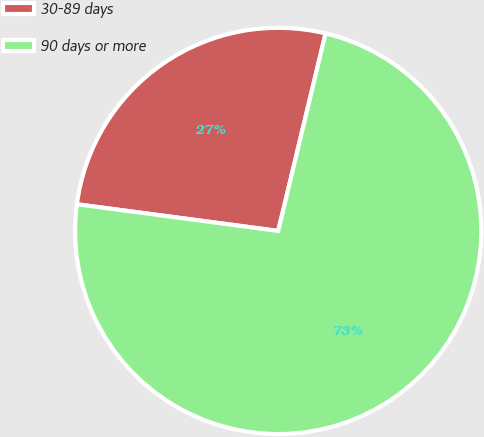<chart> <loc_0><loc_0><loc_500><loc_500><pie_chart><fcel>30-89 days<fcel>90 days or more<nl><fcel>26.65%<fcel>73.35%<nl></chart> 